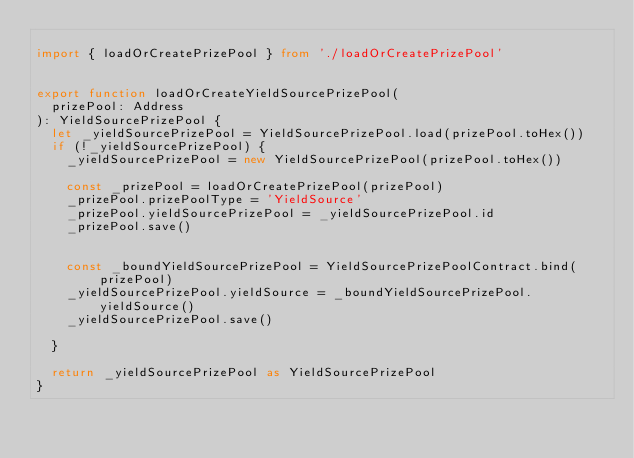<code> <loc_0><loc_0><loc_500><loc_500><_TypeScript_>
import { loadOrCreatePrizePool } from './loadOrCreatePrizePool'


export function loadOrCreateYieldSourcePrizePool(
  prizePool: Address
): YieldSourcePrizePool {
  let _yieldSourcePrizePool = YieldSourcePrizePool.load(prizePool.toHex())
  if (!_yieldSourcePrizePool) {
    _yieldSourcePrizePool = new YieldSourcePrizePool(prizePool.toHex())

    const _prizePool = loadOrCreatePrizePool(prizePool)
    _prizePool.prizePoolType = 'YieldSource'
    _prizePool.yieldSourcePrizePool = _yieldSourcePrizePool.id
    _prizePool.save()


    const _boundYieldSourcePrizePool = YieldSourcePrizePoolContract.bind(prizePool)
    _yieldSourcePrizePool.yieldSource = _boundYieldSourcePrizePool.yieldSource()
    _yieldSourcePrizePool.save()

  }

  return _yieldSourcePrizePool as YieldSourcePrizePool
}
</code> 